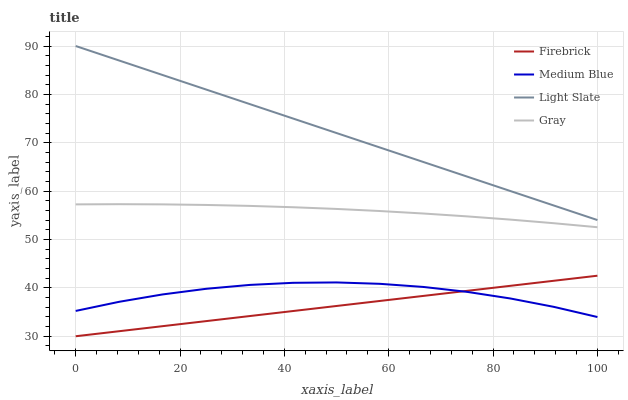Does Firebrick have the minimum area under the curve?
Answer yes or no. Yes. Does Light Slate have the maximum area under the curve?
Answer yes or no. Yes. Does Gray have the minimum area under the curve?
Answer yes or no. No. Does Gray have the maximum area under the curve?
Answer yes or no. No. Is Firebrick the smoothest?
Answer yes or no. Yes. Is Medium Blue the roughest?
Answer yes or no. Yes. Is Gray the smoothest?
Answer yes or no. No. Is Gray the roughest?
Answer yes or no. No. Does Firebrick have the lowest value?
Answer yes or no. Yes. Does Gray have the lowest value?
Answer yes or no. No. Does Light Slate have the highest value?
Answer yes or no. Yes. Does Gray have the highest value?
Answer yes or no. No. Is Firebrick less than Light Slate?
Answer yes or no. Yes. Is Light Slate greater than Gray?
Answer yes or no. Yes. Does Medium Blue intersect Firebrick?
Answer yes or no. Yes. Is Medium Blue less than Firebrick?
Answer yes or no. No. Is Medium Blue greater than Firebrick?
Answer yes or no. No. Does Firebrick intersect Light Slate?
Answer yes or no. No. 